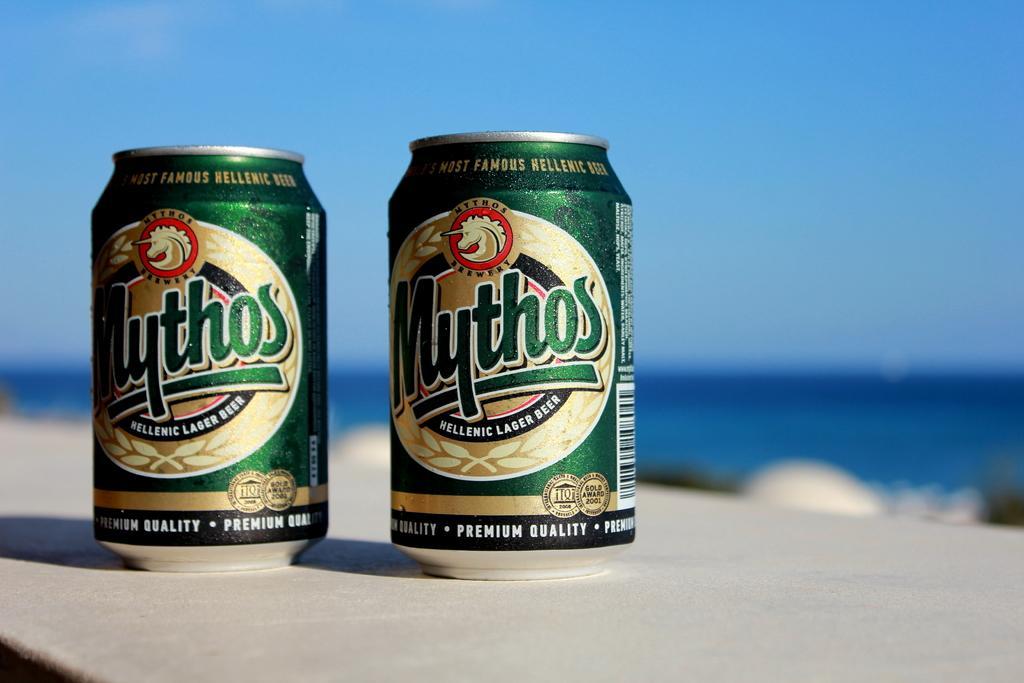Please provide a concise description of this image. There are two cans and something is written on that. And they are on a surface. In the background it is blurred. 